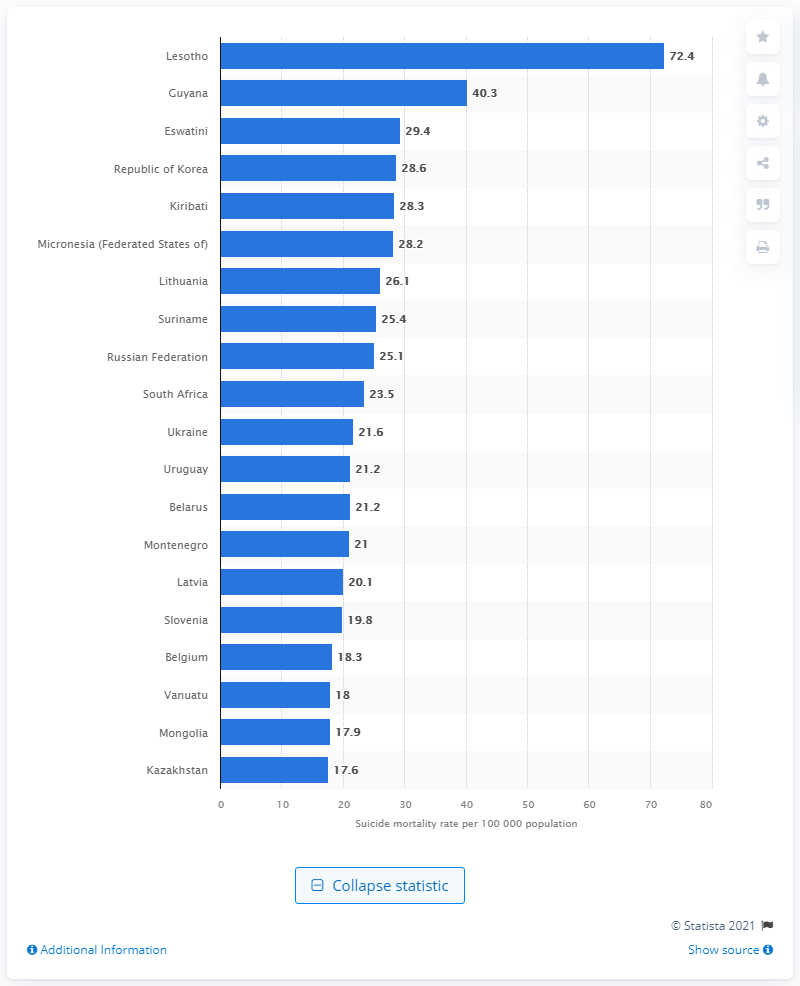Indicate a few pertinent items in this graphic. Lithuania has the highest suicide rate for men as of 2017. 